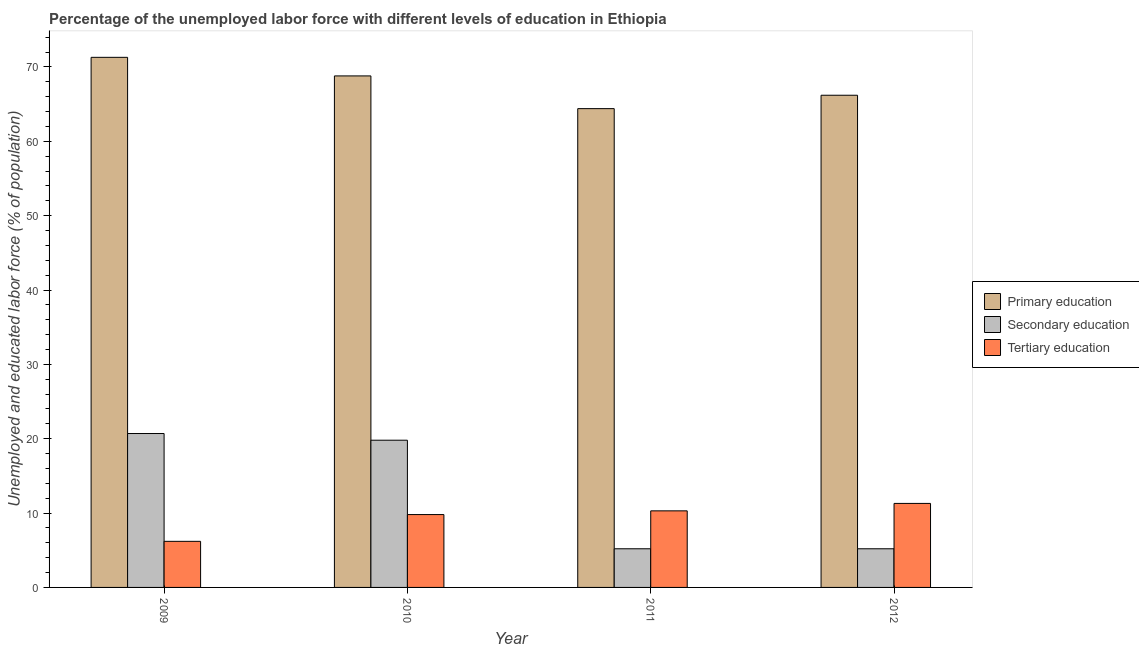How many different coloured bars are there?
Give a very brief answer. 3. Are the number of bars per tick equal to the number of legend labels?
Make the answer very short. Yes. Are the number of bars on each tick of the X-axis equal?
Make the answer very short. Yes. How many bars are there on the 2nd tick from the left?
Your answer should be compact. 3. How many bars are there on the 1st tick from the right?
Ensure brevity in your answer.  3. What is the label of the 1st group of bars from the left?
Your answer should be compact. 2009. In how many cases, is the number of bars for a given year not equal to the number of legend labels?
Give a very brief answer. 0. What is the percentage of labor force who received primary education in 2011?
Provide a succinct answer. 64.4. Across all years, what is the maximum percentage of labor force who received tertiary education?
Offer a very short reply. 11.3. Across all years, what is the minimum percentage of labor force who received tertiary education?
Ensure brevity in your answer.  6.2. In which year was the percentage of labor force who received secondary education minimum?
Ensure brevity in your answer.  2011. What is the total percentage of labor force who received tertiary education in the graph?
Your response must be concise. 37.6. What is the difference between the percentage of labor force who received primary education in 2009 and that in 2012?
Your response must be concise. 5.1. What is the difference between the percentage of labor force who received secondary education in 2010 and the percentage of labor force who received tertiary education in 2009?
Offer a very short reply. -0.9. What is the average percentage of labor force who received secondary education per year?
Make the answer very short. 12.72. What is the ratio of the percentage of labor force who received primary education in 2010 to that in 2012?
Make the answer very short. 1.04. Is the percentage of labor force who received primary education in 2009 less than that in 2012?
Keep it short and to the point. No. Is the difference between the percentage of labor force who received primary education in 2010 and 2011 greater than the difference between the percentage of labor force who received secondary education in 2010 and 2011?
Provide a succinct answer. No. What is the difference between the highest and the second highest percentage of labor force who received secondary education?
Offer a very short reply. 0.9. What is the difference between the highest and the lowest percentage of labor force who received primary education?
Give a very brief answer. 6.9. What does the 1st bar from the left in 2012 represents?
Offer a terse response. Primary education. What does the 3rd bar from the right in 2010 represents?
Give a very brief answer. Primary education. Are the values on the major ticks of Y-axis written in scientific E-notation?
Provide a succinct answer. No. Does the graph contain any zero values?
Your answer should be very brief. No. Does the graph contain grids?
Provide a succinct answer. No. Where does the legend appear in the graph?
Give a very brief answer. Center right. How are the legend labels stacked?
Provide a succinct answer. Vertical. What is the title of the graph?
Keep it short and to the point. Percentage of the unemployed labor force with different levels of education in Ethiopia. What is the label or title of the X-axis?
Your answer should be compact. Year. What is the label or title of the Y-axis?
Ensure brevity in your answer.  Unemployed and educated labor force (% of population). What is the Unemployed and educated labor force (% of population) in Primary education in 2009?
Offer a very short reply. 71.3. What is the Unemployed and educated labor force (% of population) in Secondary education in 2009?
Your answer should be compact. 20.7. What is the Unemployed and educated labor force (% of population) in Tertiary education in 2009?
Keep it short and to the point. 6.2. What is the Unemployed and educated labor force (% of population) in Primary education in 2010?
Offer a very short reply. 68.8. What is the Unemployed and educated labor force (% of population) in Secondary education in 2010?
Your answer should be very brief. 19.8. What is the Unemployed and educated labor force (% of population) in Tertiary education in 2010?
Your answer should be very brief. 9.8. What is the Unemployed and educated labor force (% of population) in Primary education in 2011?
Offer a very short reply. 64.4. What is the Unemployed and educated labor force (% of population) of Secondary education in 2011?
Provide a short and direct response. 5.2. What is the Unemployed and educated labor force (% of population) in Tertiary education in 2011?
Your answer should be very brief. 10.3. What is the Unemployed and educated labor force (% of population) in Primary education in 2012?
Keep it short and to the point. 66.2. What is the Unemployed and educated labor force (% of population) of Secondary education in 2012?
Ensure brevity in your answer.  5.2. What is the Unemployed and educated labor force (% of population) of Tertiary education in 2012?
Offer a very short reply. 11.3. Across all years, what is the maximum Unemployed and educated labor force (% of population) in Primary education?
Your answer should be very brief. 71.3. Across all years, what is the maximum Unemployed and educated labor force (% of population) of Secondary education?
Provide a succinct answer. 20.7. Across all years, what is the maximum Unemployed and educated labor force (% of population) in Tertiary education?
Provide a short and direct response. 11.3. Across all years, what is the minimum Unemployed and educated labor force (% of population) in Primary education?
Offer a terse response. 64.4. Across all years, what is the minimum Unemployed and educated labor force (% of population) in Secondary education?
Offer a terse response. 5.2. Across all years, what is the minimum Unemployed and educated labor force (% of population) of Tertiary education?
Ensure brevity in your answer.  6.2. What is the total Unemployed and educated labor force (% of population) of Primary education in the graph?
Your answer should be very brief. 270.7. What is the total Unemployed and educated labor force (% of population) of Secondary education in the graph?
Give a very brief answer. 50.9. What is the total Unemployed and educated labor force (% of population) in Tertiary education in the graph?
Your answer should be very brief. 37.6. What is the difference between the Unemployed and educated labor force (% of population) of Primary education in 2009 and that in 2010?
Ensure brevity in your answer.  2.5. What is the difference between the Unemployed and educated labor force (% of population) of Secondary education in 2009 and that in 2010?
Offer a very short reply. 0.9. What is the difference between the Unemployed and educated labor force (% of population) of Primary education in 2009 and that in 2011?
Ensure brevity in your answer.  6.9. What is the difference between the Unemployed and educated labor force (% of population) in Tertiary education in 2009 and that in 2011?
Provide a succinct answer. -4.1. What is the difference between the Unemployed and educated labor force (% of population) of Secondary education in 2010 and that in 2011?
Your answer should be very brief. 14.6. What is the difference between the Unemployed and educated labor force (% of population) of Secondary education in 2010 and that in 2012?
Keep it short and to the point. 14.6. What is the difference between the Unemployed and educated labor force (% of population) in Primary education in 2011 and that in 2012?
Provide a short and direct response. -1.8. What is the difference between the Unemployed and educated labor force (% of population) in Primary education in 2009 and the Unemployed and educated labor force (% of population) in Secondary education in 2010?
Your response must be concise. 51.5. What is the difference between the Unemployed and educated labor force (% of population) of Primary education in 2009 and the Unemployed and educated labor force (% of population) of Tertiary education in 2010?
Your answer should be very brief. 61.5. What is the difference between the Unemployed and educated labor force (% of population) of Secondary education in 2009 and the Unemployed and educated labor force (% of population) of Tertiary education in 2010?
Make the answer very short. 10.9. What is the difference between the Unemployed and educated labor force (% of population) of Primary education in 2009 and the Unemployed and educated labor force (% of population) of Secondary education in 2011?
Offer a very short reply. 66.1. What is the difference between the Unemployed and educated labor force (% of population) of Primary education in 2009 and the Unemployed and educated labor force (% of population) of Secondary education in 2012?
Your response must be concise. 66.1. What is the difference between the Unemployed and educated labor force (% of population) in Primary education in 2009 and the Unemployed and educated labor force (% of population) in Tertiary education in 2012?
Ensure brevity in your answer.  60. What is the difference between the Unemployed and educated labor force (% of population) in Primary education in 2010 and the Unemployed and educated labor force (% of population) in Secondary education in 2011?
Provide a short and direct response. 63.6. What is the difference between the Unemployed and educated labor force (% of population) of Primary education in 2010 and the Unemployed and educated labor force (% of population) of Tertiary education in 2011?
Offer a terse response. 58.5. What is the difference between the Unemployed and educated labor force (% of population) of Secondary education in 2010 and the Unemployed and educated labor force (% of population) of Tertiary education in 2011?
Provide a succinct answer. 9.5. What is the difference between the Unemployed and educated labor force (% of population) in Primary education in 2010 and the Unemployed and educated labor force (% of population) in Secondary education in 2012?
Provide a short and direct response. 63.6. What is the difference between the Unemployed and educated labor force (% of population) in Primary education in 2010 and the Unemployed and educated labor force (% of population) in Tertiary education in 2012?
Provide a succinct answer. 57.5. What is the difference between the Unemployed and educated labor force (% of population) in Secondary education in 2010 and the Unemployed and educated labor force (% of population) in Tertiary education in 2012?
Give a very brief answer. 8.5. What is the difference between the Unemployed and educated labor force (% of population) of Primary education in 2011 and the Unemployed and educated labor force (% of population) of Secondary education in 2012?
Offer a terse response. 59.2. What is the difference between the Unemployed and educated labor force (% of population) in Primary education in 2011 and the Unemployed and educated labor force (% of population) in Tertiary education in 2012?
Keep it short and to the point. 53.1. What is the difference between the Unemployed and educated labor force (% of population) in Secondary education in 2011 and the Unemployed and educated labor force (% of population) in Tertiary education in 2012?
Your response must be concise. -6.1. What is the average Unemployed and educated labor force (% of population) of Primary education per year?
Provide a short and direct response. 67.67. What is the average Unemployed and educated labor force (% of population) of Secondary education per year?
Keep it short and to the point. 12.72. In the year 2009, what is the difference between the Unemployed and educated labor force (% of population) in Primary education and Unemployed and educated labor force (% of population) in Secondary education?
Ensure brevity in your answer.  50.6. In the year 2009, what is the difference between the Unemployed and educated labor force (% of population) in Primary education and Unemployed and educated labor force (% of population) in Tertiary education?
Offer a very short reply. 65.1. In the year 2009, what is the difference between the Unemployed and educated labor force (% of population) of Secondary education and Unemployed and educated labor force (% of population) of Tertiary education?
Provide a short and direct response. 14.5. In the year 2010, what is the difference between the Unemployed and educated labor force (% of population) in Primary education and Unemployed and educated labor force (% of population) in Secondary education?
Your response must be concise. 49. In the year 2010, what is the difference between the Unemployed and educated labor force (% of population) in Secondary education and Unemployed and educated labor force (% of population) in Tertiary education?
Your answer should be very brief. 10. In the year 2011, what is the difference between the Unemployed and educated labor force (% of population) of Primary education and Unemployed and educated labor force (% of population) of Secondary education?
Keep it short and to the point. 59.2. In the year 2011, what is the difference between the Unemployed and educated labor force (% of population) in Primary education and Unemployed and educated labor force (% of population) in Tertiary education?
Ensure brevity in your answer.  54.1. In the year 2011, what is the difference between the Unemployed and educated labor force (% of population) in Secondary education and Unemployed and educated labor force (% of population) in Tertiary education?
Provide a succinct answer. -5.1. In the year 2012, what is the difference between the Unemployed and educated labor force (% of population) of Primary education and Unemployed and educated labor force (% of population) of Tertiary education?
Give a very brief answer. 54.9. What is the ratio of the Unemployed and educated labor force (% of population) of Primary education in 2009 to that in 2010?
Offer a very short reply. 1.04. What is the ratio of the Unemployed and educated labor force (% of population) in Secondary education in 2009 to that in 2010?
Provide a succinct answer. 1.05. What is the ratio of the Unemployed and educated labor force (% of population) of Tertiary education in 2009 to that in 2010?
Offer a very short reply. 0.63. What is the ratio of the Unemployed and educated labor force (% of population) of Primary education in 2009 to that in 2011?
Keep it short and to the point. 1.11. What is the ratio of the Unemployed and educated labor force (% of population) of Secondary education in 2009 to that in 2011?
Offer a very short reply. 3.98. What is the ratio of the Unemployed and educated labor force (% of population) in Tertiary education in 2009 to that in 2011?
Your response must be concise. 0.6. What is the ratio of the Unemployed and educated labor force (% of population) of Primary education in 2009 to that in 2012?
Give a very brief answer. 1.08. What is the ratio of the Unemployed and educated labor force (% of population) of Secondary education in 2009 to that in 2012?
Ensure brevity in your answer.  3.98. What is the ratio of the Unemployed and educated labor force (% of population) in Tertiary education in 2009 to that in 2012?
Make the answer very short. 0.55. What is the ratio of the Unemployed and educated labor force (% of population) in Primary education in 2010 to that in 2011?
Ensure brevity in your answer.  1.07. What is the ratio of the Unemployed and educated labor force (% of population) in Secondary education in 2010 to that in 2011?
Keep it short and to the point. 3.81. What is the ratio of the Unemployed and educated labor force (% of population) of Tertiary education in 2010 to that in 2011?
Make the answer very short. 0.95. What is the ratio of the Unemployed and educated labor force (% of population) in Primary education in 2010 to that in 2012?
Provide a short and direct response. 1.04. What is the ratio of the Unemployed and educated labor force (% of population) of Secondary education in 2010 to that in 2012?
Offer a terse response. 3.81. What is the ratio of the Unemployed and educated labor force (% of population) in Tertiary education in 2010 to that in 2012?
Offer a very short reply. 0.87. What is the ratio of the Unemployed and educated labor force (% of population) in Primary education in 2011 to that in 2012?
Ensure brevity in your answer.  0.97. What is the ratio of the Unemployed and educated labor force (% of population) of Tertiary education in 2011 to that in 2012?
Offer a very short reply. 0.91. What is the difference between the highest and the second highest Unemployed and educated labor force (% of population) of Primary education?
Offer a terse response. 2.5. What is the difference between the highest and the second highest Unemployed and educated labor force (% of population) of Secondary education?
Offer a terse response. 0.9. What is the difference between the highest and the second highest Unemployed and educated labor force (% of population) in Tertiary education?
Make the answer very short. 1. What is the difference between the highest and the lowest Unemployed and educated labor force (% of population) of Secondary education?
Ensure brevity in your answer.  15.5. What is the difference between the highest and the lowest Unemployed and educated labor force (% of population) of Tertiary education?
Your answer should be compact. 5.1. 